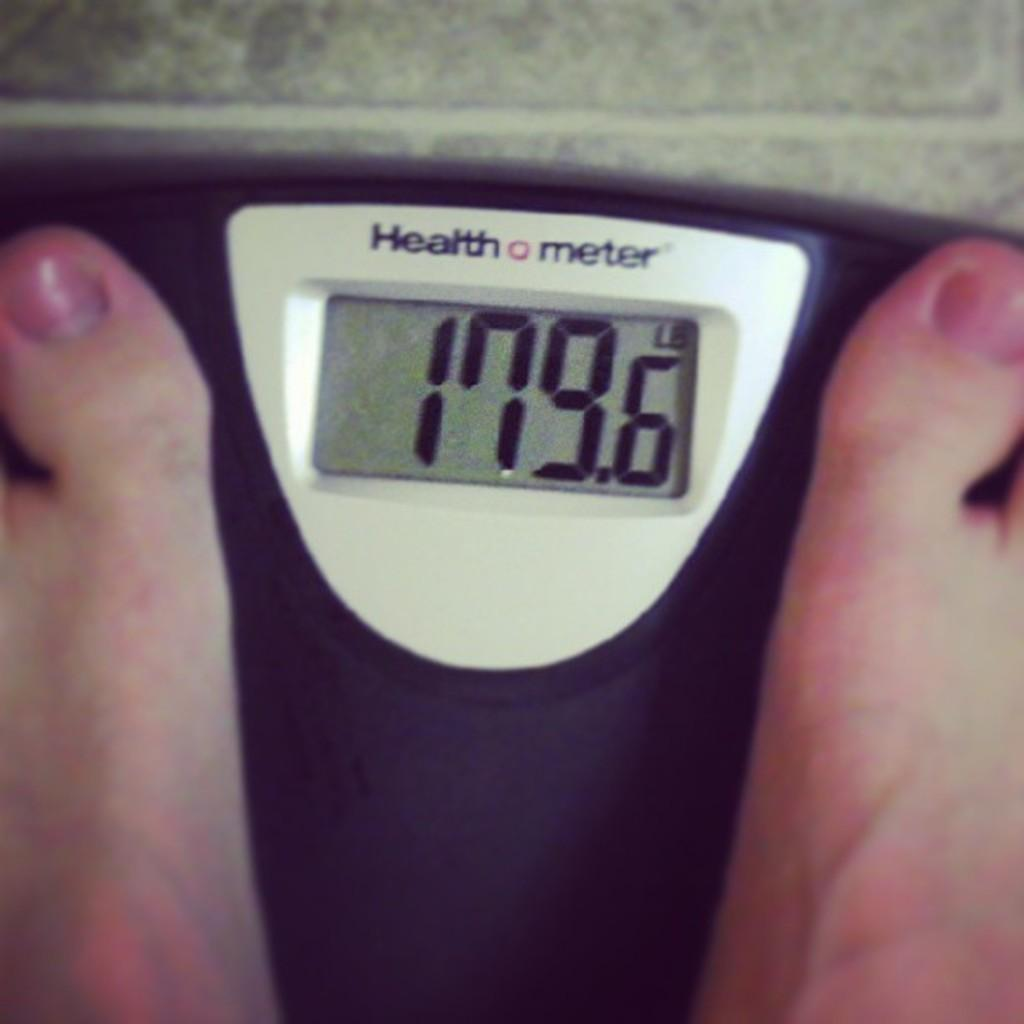Provide a one-sentence caption for the provided image. A health meter scale displays someone's weight in pounds. 